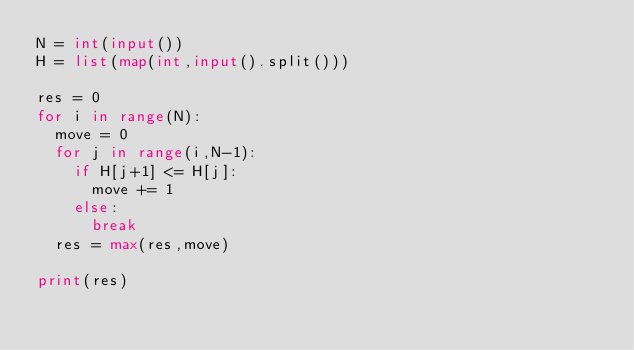<code> <loc_0><loc_0><loc_500><loc_500><_Python_>N = int(input())
H = list(map(int,input().split()))

res = 0
for i in range(N):
  move = 0
  for j in range(i,N-1):
    if H[j+1] <= H[j]:
      move += 1
    else:
      break
  res = max(res,move)

print(res)</code> 